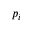Convert formula to latex. <formula><loc_0><loc_0><loc_500><loc_500>p _ { i }</formula> 